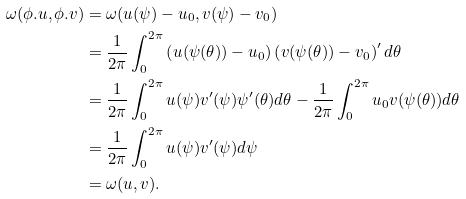<formula> <loc_0><loc_0><loc_500><loc_500>\omega ( \phi . u , \phi . v ) & = \omega ( u ( \psi ) - u _ { 0 } , v ( \psi ) - v _ { 0 } ) \\ & = \frac { 1 } { 2 \pi } \int _ { 0 } ^ { 2 \pi } \left ( u ( \psi ( \theta ) ) - u _ { 0 } \right ) \left ( v ( \psi ( \theta ) ) - v _ { 0 } \right ) ^ { \prime } d \theta \\ & = \frac { 1 } { 2 \pi } \int _ { 0 } ^ { 2 \pi } u ( \psi ) v ^ { \prime } ( \psi ) \psi ^ { \prime } ( \theta ) d \theta - \frac { 1 } { 2 \pi } \int _ { 0 } ^ { 2 \pi } u _ { 0 } v ( \psi ( \theta ) ) d \theta \\ & = \frac { 1 } { 2 \pi } \int _ { 0 } ^ { 2 \pi } u ( \psi ) v ^ { \prime } ( \psi ) d \psi \\ & = \omega ( u , v ) .</formula> 